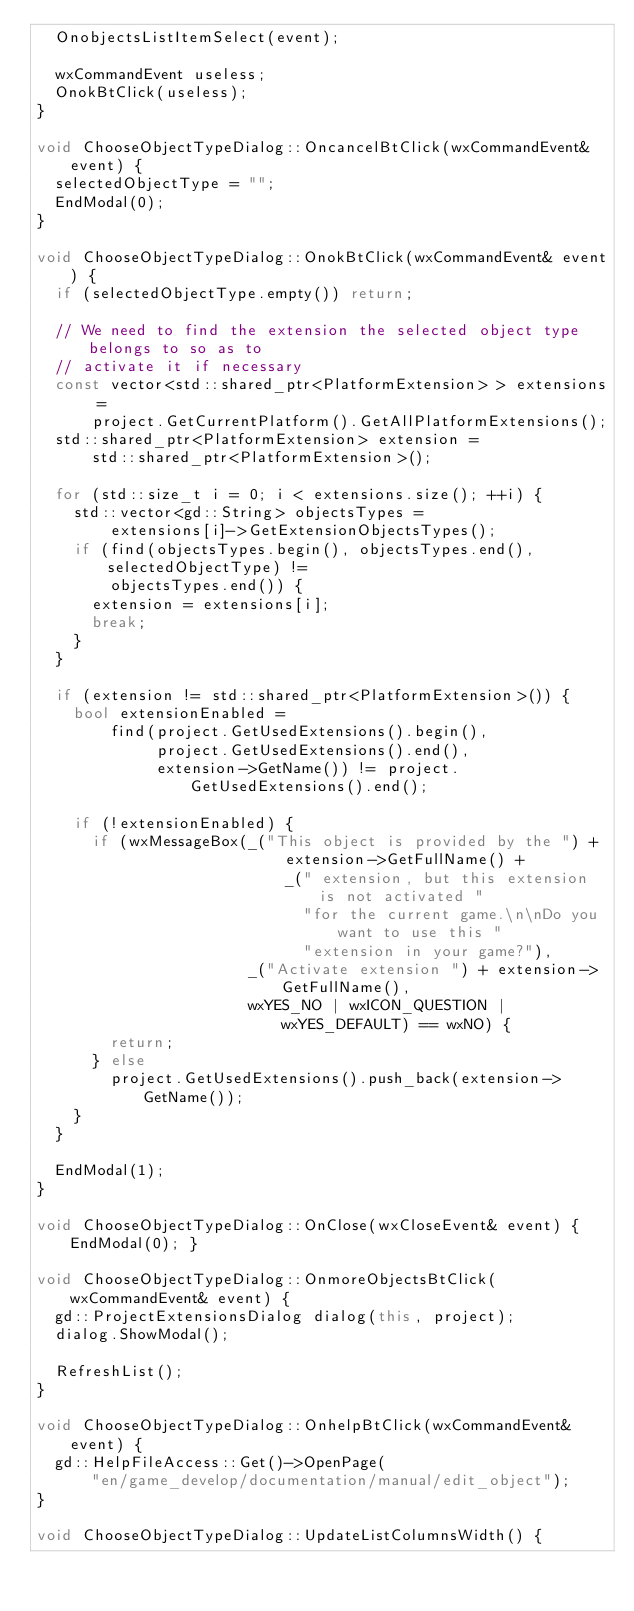Convert code to text. <code><loc_0><loc_0><loc_500><loc_500><_C++_>  OnobjectsListItemSelect(event);

  wxCommandEvent useless;
  OnokBtClick(useless);
}

void ChooseObjectTypeDialog::OncancelBtClick(wxCommandEvent& event) {
  selectedObjectType = "";
  EndModal(0);
}

void ChooseObjectTypeDialog::OnokBtClick(wxCommandEvent& event) {
  if (selectedObjectType.empty()) return;

  // We need to find the extension the selected object type belongs to so as to
  // activate it if necessary
  const vector<std::shared_ptr<PlatformExtension> > extensions =
      project.GetCurrentPlatform().GetAllPlatformExtensions();
  std::shared_ptr<PlatformExtension> extension =
      std::shared_ptr<PlatformExtension>();

  for (std::size_t i = 0; i < extensions.size(); ++i) {
    std::vector<gd::String> objectsTypes =
        extensions[i]->GetExtensionObjectsTypes();
    if (find(objectsTypes.begin(), objectsTypes.end(), selectedObjectType) !=
        objectsTypes.end()) {
      extension = extensions[i];
      break;
    }
  }

  if (extension != std::shared_ptr<PlatformExtension>()) {
    bool extensionEnabled =
        find(project.GetUsedExtensions().begin(),
             project.GetUsedExtensions().end(),
             extension->GetName()) != project.GetUsedExtensions().end();

    if (!extensionEnabled) {
      if (wxMessageBox(_("This object is provided by the ") +
                           extension->GetFullName() +
                           _(" extension, but this extension is not activated "
                             "for the current game.\n\nDo you want to use this "
                             "extension in your game?"),
                       _("Activate extension ") + extension->GetFullName(),
                       wxYES_NO | wxICON_QUESTION | wxYES_DEFAULT) == wxNO) {
        return;
      } else
        project.GetUsedExtensions().push_back(extension->GetName());
    }
  }

  EndModal(1);
}

void ChooseObjectTypeDialog::OnClose(wxCloseEvent& event) { EndModal(0); }

void ChooseObjectTypeDialog::OnmoreObjectsBtClick(wxCommandEvent& event) {
  gd::ProjectExtensionsDialog dialog(this, project);
  dialog.ShowModal();

  RefreshList();
}

void ChooseObjectTypeDialog::OnhelpBtClick(wxCommandEvent& event) {
  gd::HelpFileAccess::Get()->OpenPage(
      "en/game_develop/documentation/manual/edit_object");
}

void ChooseObjectTypeDialog::UpdateListColumnsWidth() {</code> 